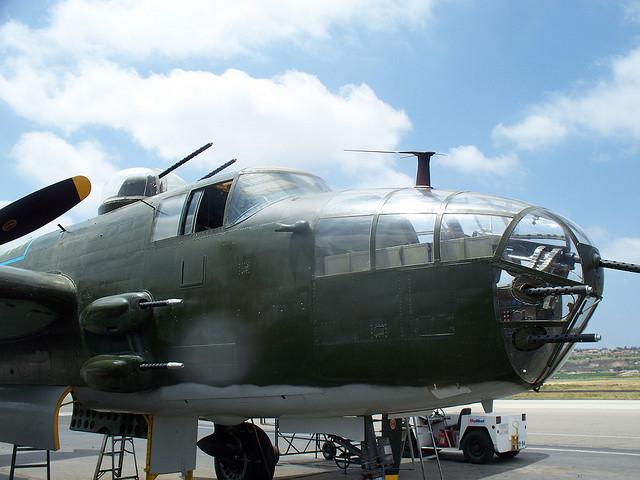Can you shoot from this plane?
Be succinct. Yes. Who is inside the plane?
Concise answer only. Pilot. Are there clouds?
Concise answer only. Yes. 